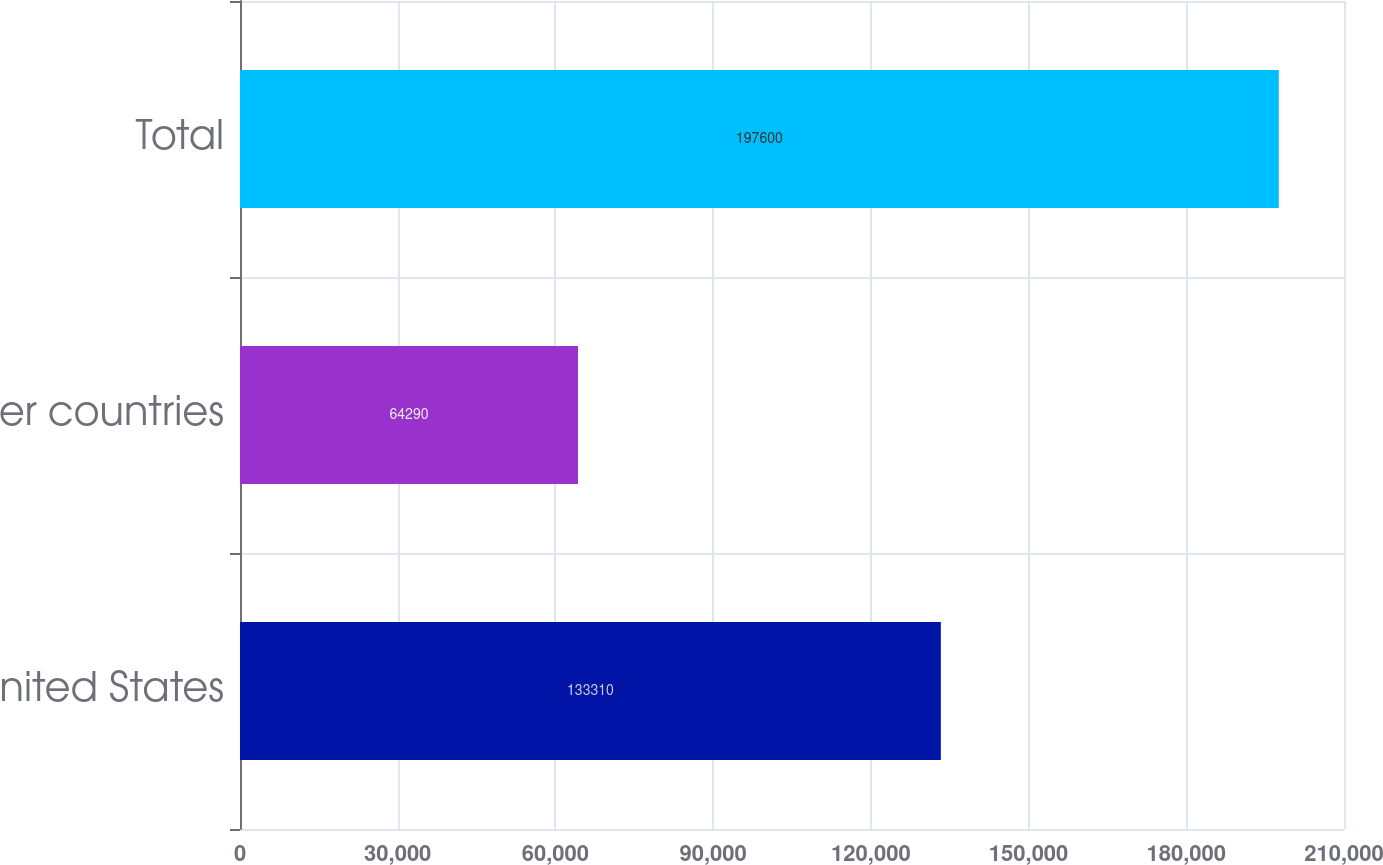Convert chart. <chart><loc_0><loc_0><loc_500><loc_500><bar_chart><fcel>United States<fcel>Other countries<fcel>Total<nl><fcel>133310<fcel>64290<fcel>197600<nl></chart> 